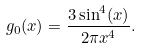<formula> <loc_0><loc_0><loc_500><loc_500>g _ { 0 } ( x ) = \frac { 3 \sin ^ { 4 } ( x ) } { 2 \pi x ^ { 4 } } .</formula> 